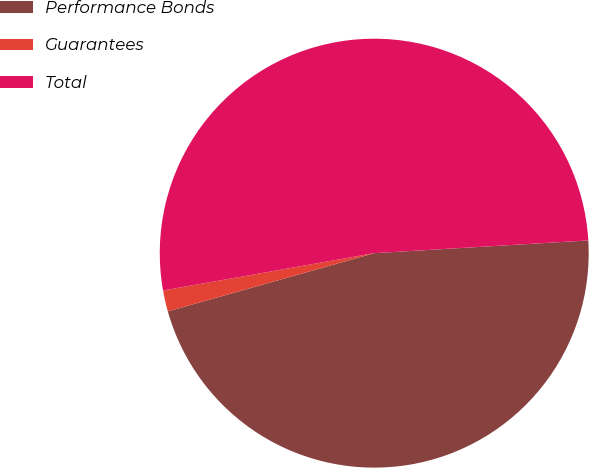Convert chart to OTSL. <chart><loc_0><loc_0><loc_500><loc_500><pie_chart><fcel>Performance Bonds<fcel>Guarantees<fcel>Total<nl><fcel>46.57%<fcel>1.59%<fcel>51.84%<nl></chart> 